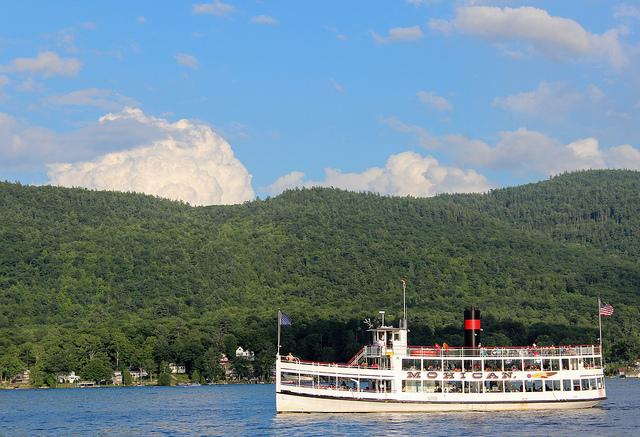Who is on the boat?

Choices:
A) escapees
B) convicts
C) tourists
D) swimmers tourists 